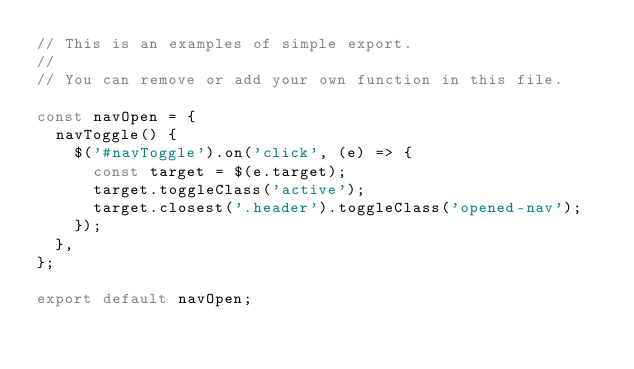<code> <loc_0><loc_0><loc_500><loc_500><_JavaScript_>// This is an examples of simple export.
//
// You can remove or add your own function in this file.

const navOpen = {
  navToggle() {
    $('#navToggle').on('click', (e) => {
      const target = $(e.target);
      target.toggleClass('active');
      target.closest('.header').toggleClass('opened-nav');
    });
  },
};

export default navOpen;
</code> 